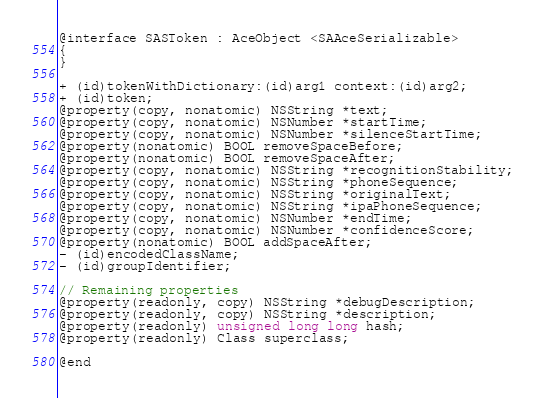<code> <loc_0><loc_0><loc_500><loc_500><_C_>@interface SASToken : AceObject <SAAceSerializable>
{
}

+ (id)tokenWithDictionary:(id)arg1 context:(id)arg2;
+ (id)token;
@property(copy, nonatomic) NSString *text;
@property(copy, nonatomic) NSNumber *startTime;
@property(copy, nonatomic) NSNumber *silenceStartTime;
@property(nonatomic) BOOL removeSpaceBefore;
@property(nonatomic) BOOL removeSpaceAfter;
@property(copy, nonatomic) NSString *recognitionStability;
@property(copy, nonatomic) NSString *phoneSequence;
@property(copy, nonatomic) NSString *originalText;
@property(copy, nonatomic) NSString *ipaPhoneSequence;
@property(copy, nonatomic) NSNumber *endTime;
@property(copy, nonatomic) NSNumber *confidenceScore;
@property(nonatomic) BOOL addSpaceAfter;
- (id)encodedClassName;
- (id)groupIdentifier;

// Remaining properties
@property(readonly, copy) NSString *debugDescription;
@property(readonly, copy) NSString *description;
@property(readonly) unsigned long long hash;
@property(readonly) Class superclass;

@end

</code> 